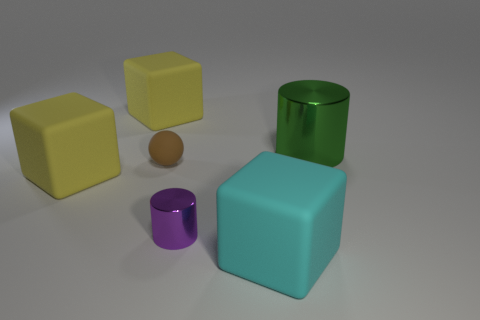Subtract all cyan cubes. How many cubes are left? 2 Subtract all cyan rubber cubes. How many cubes are left? 2 How many yellow cubes must be subtracted to get 1 yellow cubes? 1 Subtract all brown cylinders. Subtract all green balls. How many cylinders are left? 2 Subtract all brown balls. How many cyan cubes are left? 1 Subtract all purple metal cylinders. Subtract all large cylinders. How many objects are left? 4 Add 6 spheres. How many spheres are left? 7 Add 3 large green metallic things. How many large green metallic things exist? 4 Add 2 cyan blocks. How many objects exist? 8 Subtract 0 purple balls. How many objects are left? 6 